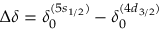<formula> <loc_0><loc_0><loc_500><loc_500>\Delta \delta = \delta _ { 0 } ^ { ( 5 s _ { 1 / 2 } ) } - \delta _ { 0 } ^ { ( 4 d _ { 3 / 2 } ) }</formula> 